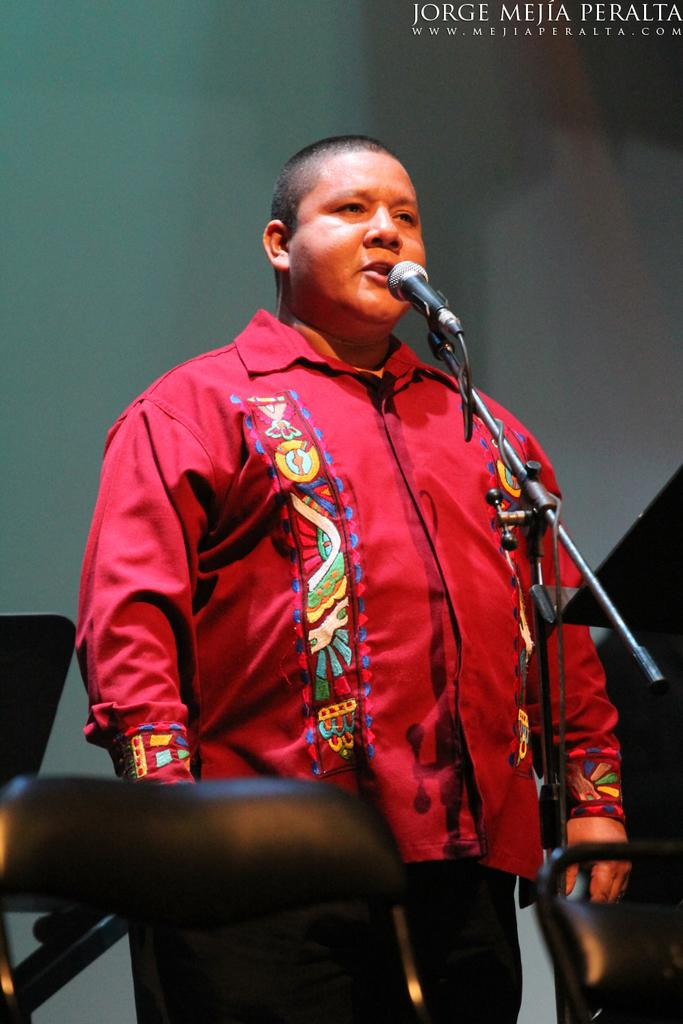Who or what is the main subject in the image? There is a person in the image. What can be observed about the person's attire? The person is wearing clothes. What is the person doing in the image? The person is standing in front of a mic. Can you describe any other objects or features in the image? There is a seat in the bottom left of the image. What type of drug is the person taking in the image? There is no indication of any drug in the image; the person is simply standing in front of a mic. 